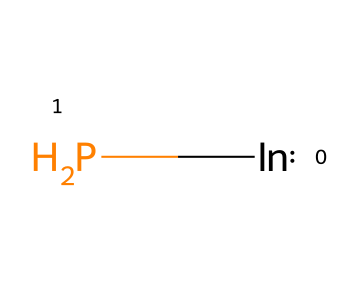What is the chemical formula for indium phosphide? The components of the chemical are identified as indium (In) and phosphorus (P), thus the formula is represented as InP.
Answer: InP How many atoms are present in the chemical structure? The chemical consists of one indium atom and one phosphorus atom, totaling two atoms in the structure.
Answer: 2 What type of bonding is present in indium phosphide? The structure contains a covalent bond formed between indium and phosphorus atoms, which is characteristic of semiconductors like indium phosphide.
Answer: covalent What is the primary use of indium phosphide quantum dots? Indium phosphide quantum dots are primarily utilized in applications such as solar cells, owing to their efficient light absorption and electron mobility, enhancing sustainable energy solutions.
Answer: solar cells How does the bandgap of indium phosphide influence its application in solar technology? The bandgap of indium phosphide is approximately 1.34 eV, making it well-suited for absorbing a significant portion of the solar spectrum, thus improving the efficiency of solar panels.
Answer: 1.34 eV Why are indium phosphide quantum dots preferred over other quantum dots for energy applications? Indium phosphide quantum dots are favored due to their lower toxicity, better electronic properties, and suitability for optoelectronic applications compared to other quantum dot materials.
Answer: lower toxicity 